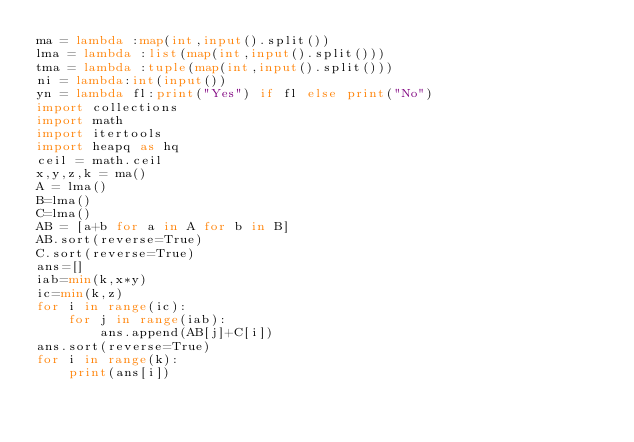<code> <loc_0><loc_0><loc_500><loc_500><_Python_>ma = lambda :map(int,input().split())
lma = lambda :list(map(int,input().split()))
tma = lambda :tuple(map(int,input().split()))
ni = lambda:int(input())
yn = lambda fl:print("Yes") if fl else print("No")
import collections
import math
import itertools
import heapq as hq
ceil = math.ceil
x,y,z,k = ma()
A = lma()
B=lma()
C=lma()
AB = [a+b for a in A for b in B]
AB.sort(reverse=True)
C.sort(reverse=True)
ans=[]
iab=min(k,x*y)
ic=min(k,z)
for i in range(ic):
    for j in range(iab):
        ans.append(AB[j]+C[i])
ans.sort(reverse=True)
for i in range(k):
    print(ans[i])
</code> 